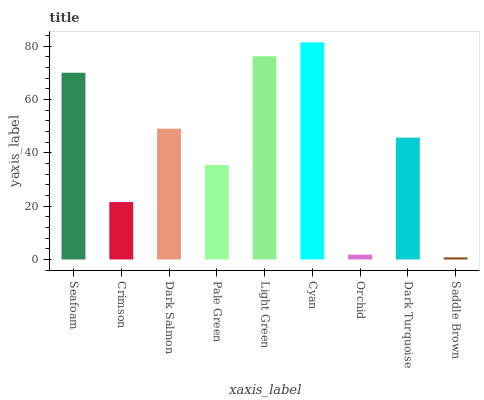Is Saddle Brown the minimum?
Answer yes or no. Yes. Is Cyan the maximum?
Answer yes or no. Yes. Is Crimson the minimum?
Answer yes or no. No. Is Crimson the maximum?
Answer yes or no. No. Is Seafoam greater than Crimson?
Answer yes or no. Yes. Is Crimson less than Seafoam?
Answer yes or no. Yes. Is Crimson greater than Seafoam?
Answer yes or no. No. Is Seafoam less than Crimson?
Answer yes or no. No. Is Dark Turquoise the high median?
Answer yes or no. Yes. Is Dark Turquoise the low median?
Answer yes or no. Yes. Is Light Green the high median?
Answer yes or no. No. Is Cyan the low median?
Answer yes or no. No. 